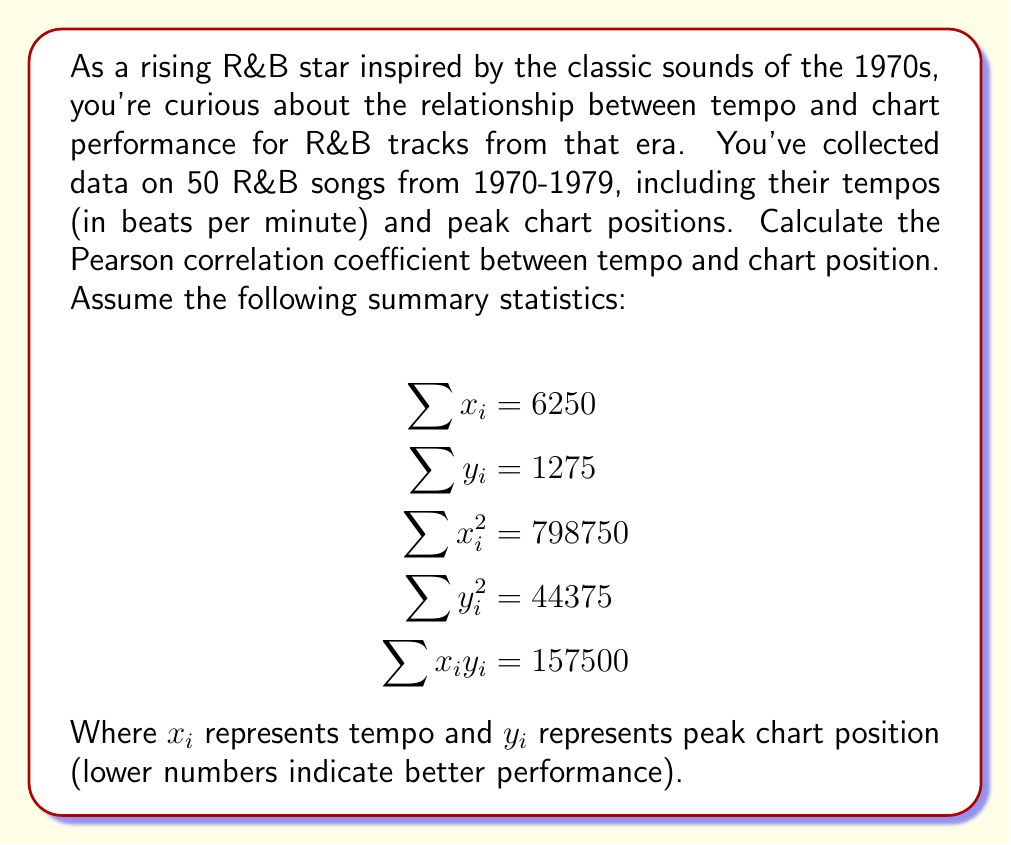What is the answer to this math problem? To calculate the Pearson correlation coefficient (r), we'll use the formula:

$$r = \frac{n\sum x_iy_i - \sum x_i \sum y_i}{\sqrt{[n\sum x_i^2 - (\sum x_i)^2][n\sum y_i^2 - (\sum y_i)^2]}}$$

Where n is the number of data points (50 in this case).

Step 1: Calculate the numerator
$$n\sum x_iy_i - \sum x_i \sum y_i = 50(157500) - 6250(1275) = 7875000 - 7968750 = -93750$$

Step 2: Calculate the first part of the denominator
$$n\sum x_i^2 - (\sum x_i)^2 = 50(798750) - 6250^2 = 39937500 - 39062500 = 875000$$

Step 3: Calculate the second part of the denominator
$$n\sum y_i^2 - (\sum y_i)^2 = 50(44375) - 1275^2 = 2218750 - 1625625 = 593125$$

Step 4: Multiply the two parts of the denominator and take the square root
$$\sqrt{875000 \times 593125} = \sqrt{518984375000} \approx 720406.18$$

Step 5: Divide the numerator by the denominator
$$r = \frac{-93750}{720406.18} \approx -0.1301$$
Answer: The Pearson correlation coefficient between tempo and chart position for the given R&B tracks from 1970-1979 is approximately -0.1301. This indicates a weak negative correlation, suggesting that as tempo increases, there is a slight tendency for chart positions to improve (remember, lower numbers indicate better chart performance). However, the correlation is quite weak, so tempo alone is not a strong predictor of chart success for R&B tracks from this era. 